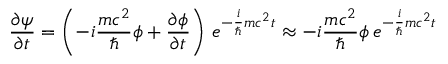Convert formula to latex. <formula><loc_0><loc_0><loc_500><loc_500>{ \frac { \partial \psi } { \partial t } } = \left ( - i { \frac { m c ^ { 2 } } { } } \phi + { \frac { \partial \phi } { \partial t } } \right ) \, e ^ { - { \frac { i } { } } m c ^ { 2 } t } \approx - i { \frac { m c ^ { 2 } } { } } \phi \, e ^ { - { \frac { i } { } } m c ^ { 2 } t }</formula> 